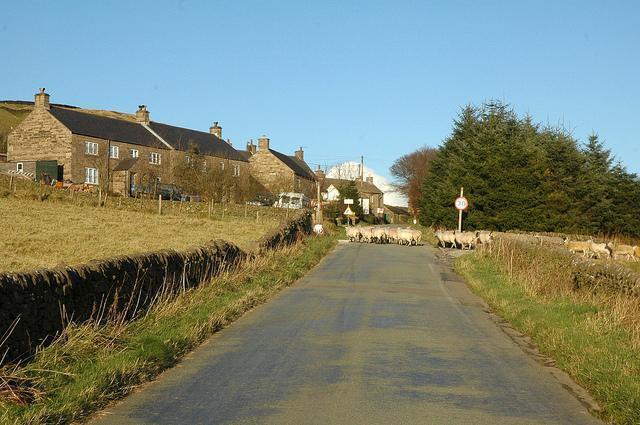How many houses are there?
Give a very brief answer. 4. How many people are there?
Give a very brief answer. 0. 